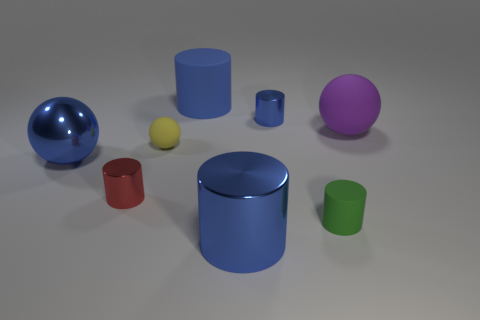Subtract all brown blocks. How many blue cylinders are left? 3 Subtract all big blue matte cylinders. How many cylinders are left? 4 Subtract all green cylinders. How many cylinders are left? 4 Subtract all brown cylinders. Subtract all cyan balls. How many cylinders are left? 5 Add 1 tiny metal cubes. How many objects exist? 9 Subtract all spheres. How many objects are left? 5 Subtract all big purple rubber balls. Subtract all large blue metal balls. How many objects are left? 6 Add 1 tiny red cylinders. How many tiny red cylinders are left? 2 Add 1 big blue metallic cylinders. How many big blue metallic cylinders exist? 2 Subtract 0 green blocks. How many objects are left? 8 